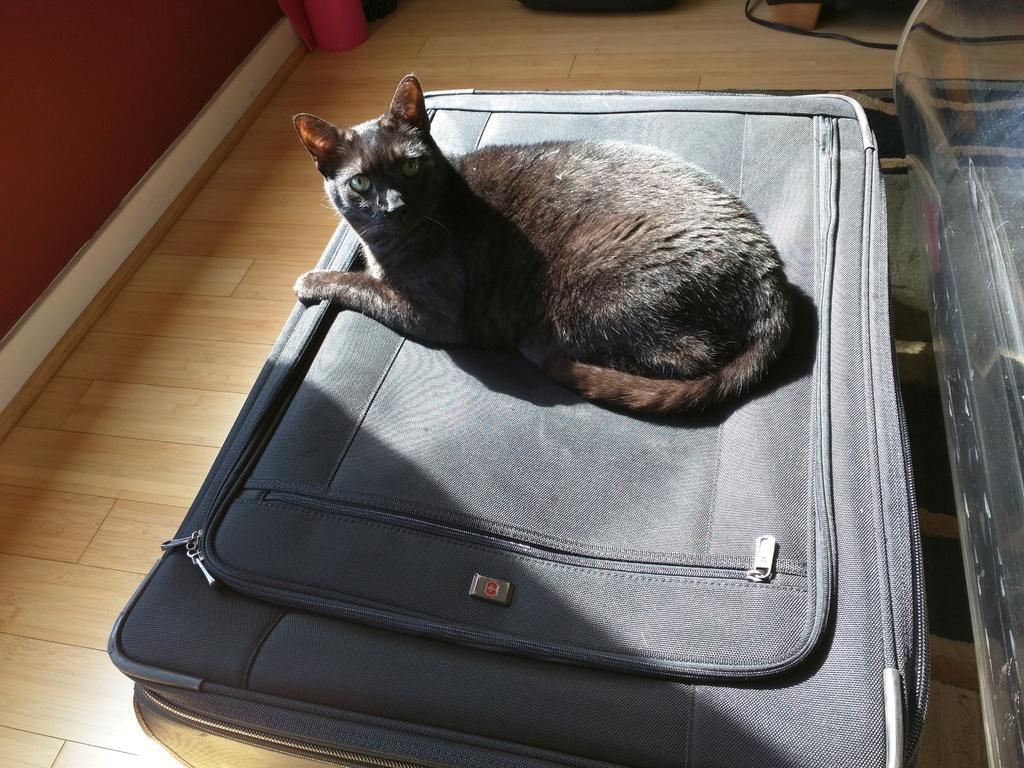How would you summarize this image in a sentence or two? In this image we can see a black cat is sitting on the luggage bag which is placed on the floor. 